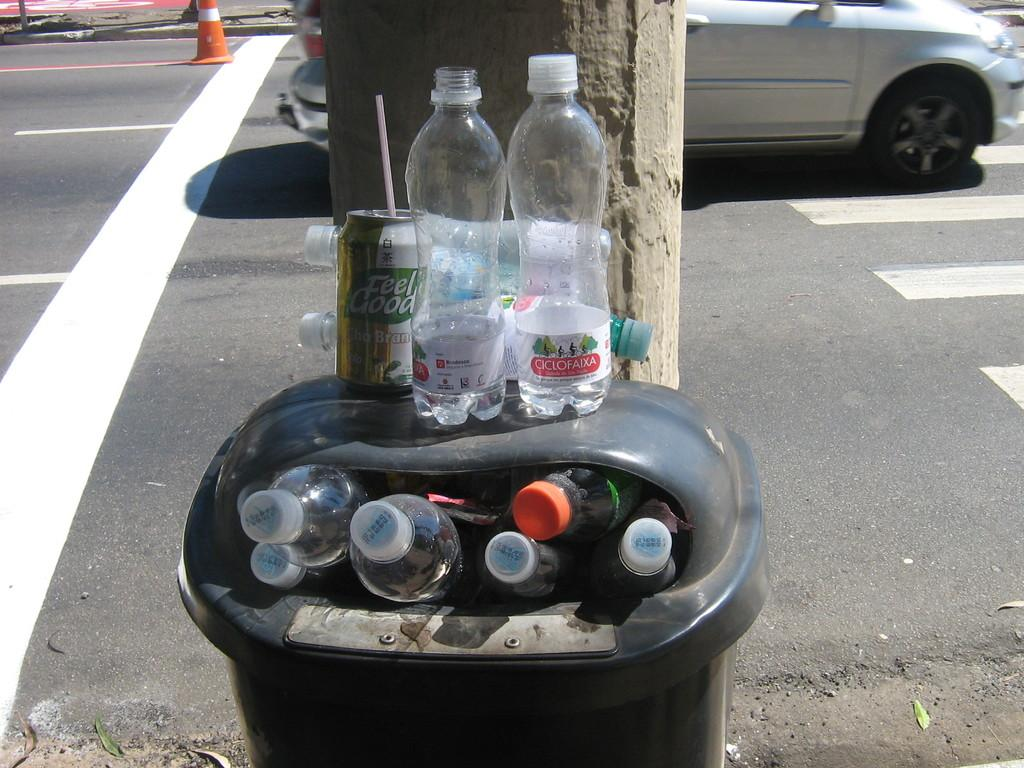What is inside the bin in the image? The bin is filled with bottles. What is located above the bin? There is a tin above the bin, and additional bottles are also above the bin. What can be seen on the road in the image? Vehicles are visible on the road. What object is present in the image that is typically used for directing traffic or indicating a hazard? There is a cone in the image. Can you see a robin perched on the cone in the image? No, there is no robin present in the image. What type of cake is being served at the event in the image? There is no event or cake present in the image. 